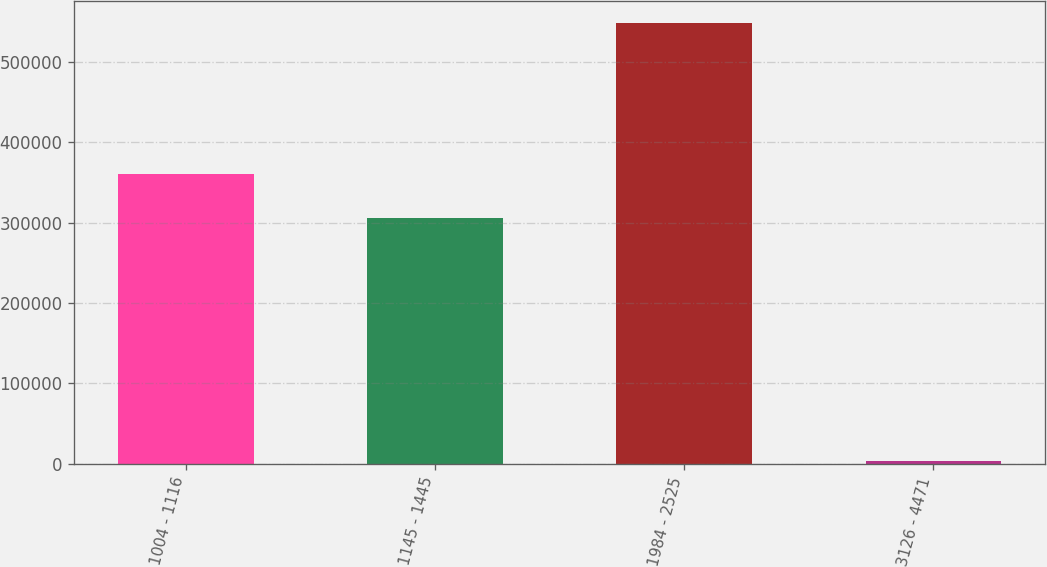Convert chart to OTSL. <chart><loc_0><loc_0><loc_500><loc_500><bar_chart><fcel>1004 - 1116<fcel>1145 - 1445<fcel>1984 - 2525<fcel>3126 - 4471<nl><fcel>360356<fcel>305888<fcel>548645<fcel>3960<nl></chart> 